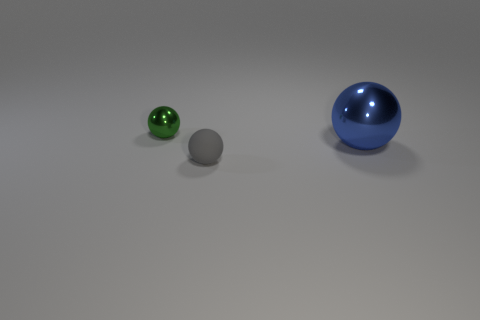Subtract all tiny balls. How many balls are left? 1 Add 1 metal spheres. How many objects exist? 4 Subtract all green balls. How many balls are left? 2 Subtract 0 cyan balls. How many objects are left? 3 Subtract 1 balls. How many balls are left? 2 Subtract all red spheres. Subtract all gray cubes. How many spheres are left? 3 Subtract all red blocks. How many gray spheres are left? 1 Subtract all large green matte cubes. Subtract all spheres. How many objects are left? 0 Add 3 tiny green spheres. How many tiny green spheres are left? 4 Add 2 cyan matte objects. How many cyan matte objects exist? 2 